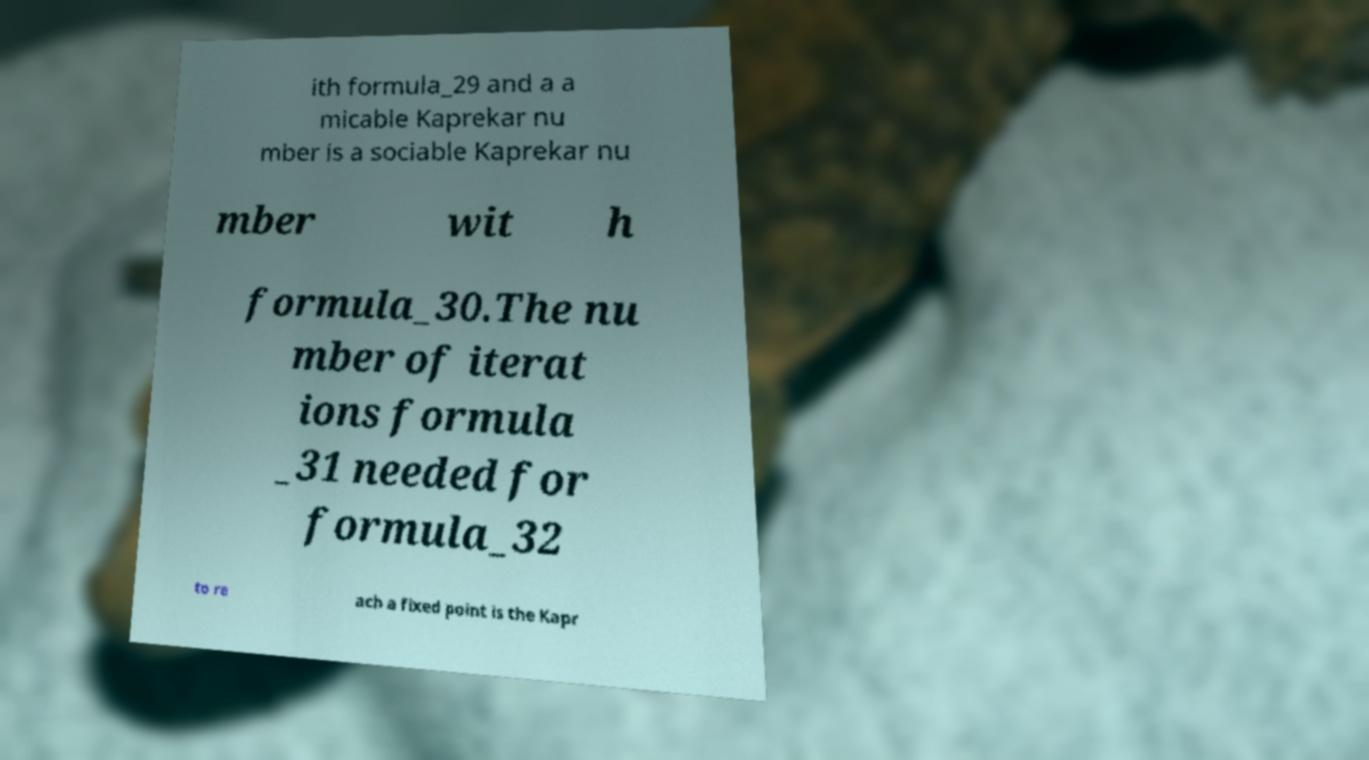Could you assist in decoding the text presented in this image and type it out clearly? ith formula_29 and a a micable Kaprekar nu mber is a sociable Kaprekar nu mber wit h formula_30.The nu mber of iterat ions formula _31 needed for formula_32 to re ach a fixed point is the Kapr 